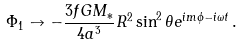Convert formula to latex. <formula><loc_0><loc_0><loc_500><loc_500>\Phi _ { 1 } \to - \frac { 3 f G M _ { * } } { 4 a ^ { 3 } } R ^ { 2 } \sin ^ { 2 } \theta e ^ { i m \phi - i \omega t } \, .</formula> 